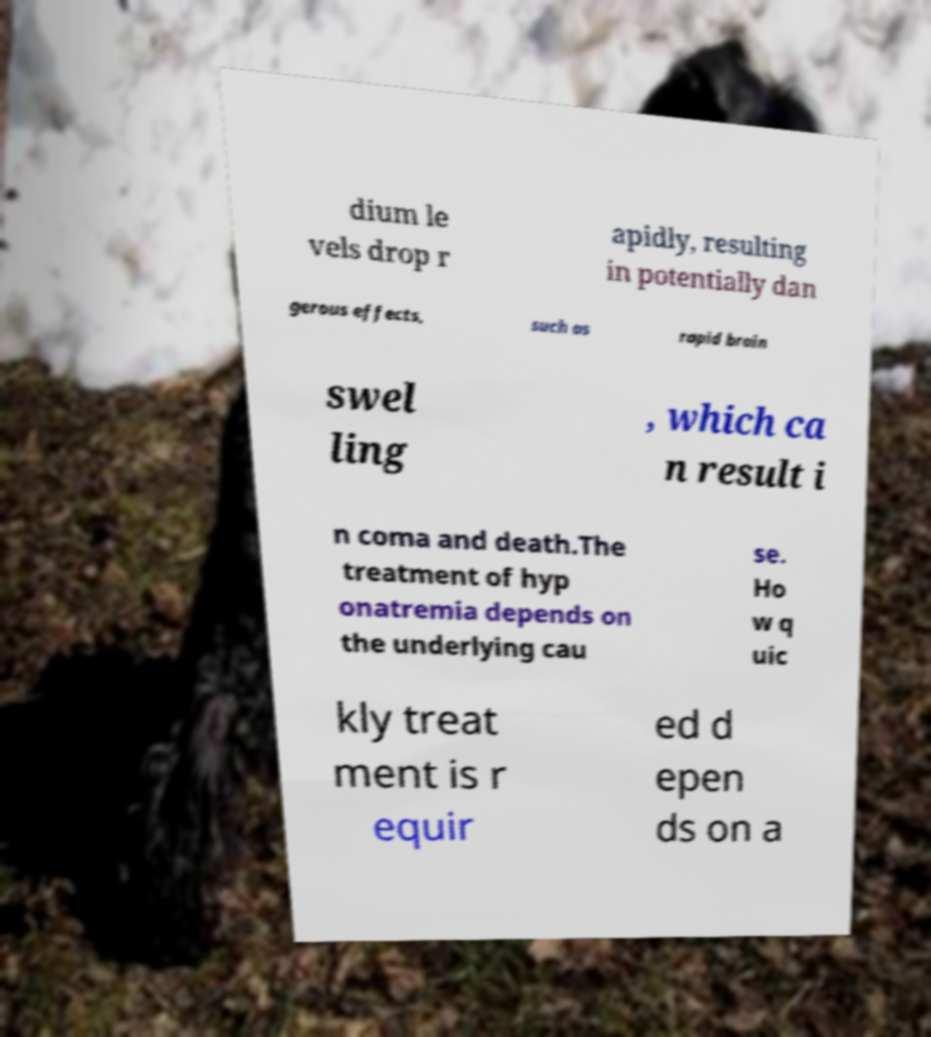Can you accurately transcribe the text from the provided image for me? dium le vels drop r apidly, resulting in potentially dan gerous effects, such as rapid brain swel ling , which ca n result i n coma and death.The treatment of hyp onatremia depends on the underlying cau se. Ho w q uic kly treat ment is r equir ed d epen ds on a 